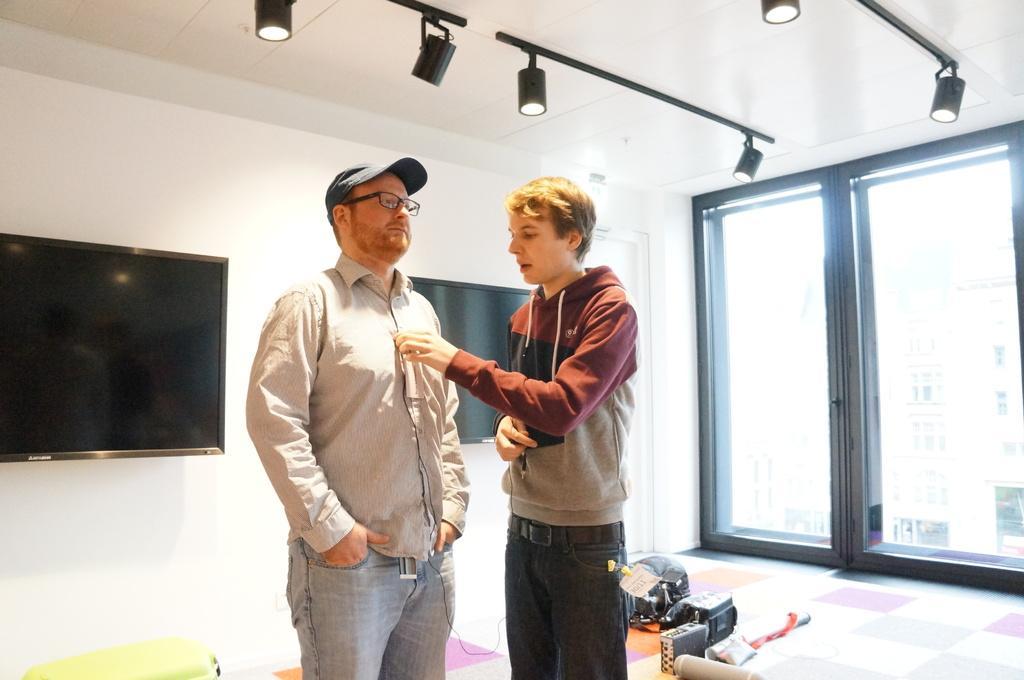Could you give a brief overview of what you see in this image? In this picture I can see two men in the middle, in the background there are televisions. At the top there are lights, on the right side those may be the glass doors. 